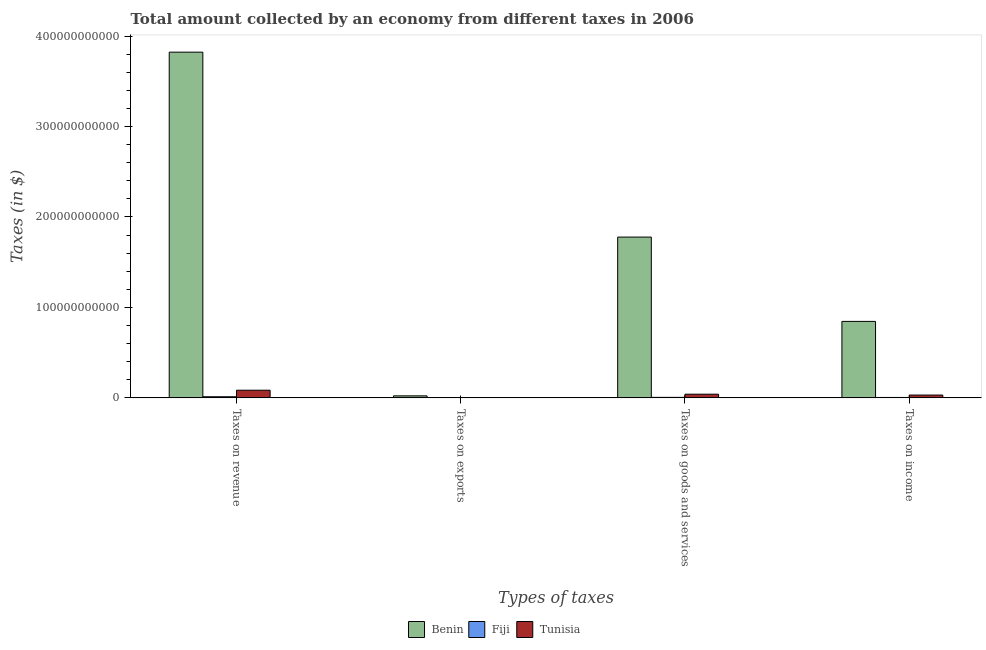How many different coloured bars are there?
Ensure brevity in your answer.  3. How many groups of bars are there?
Offer a terse response. 4. How many bars are there on the 1st tick from the left?
Offer a very short reply. 3. How many bars are there on the 1st tick from the right?
Your answer should be compact. 3. What is the label of the 4th group of bars from the left?
Provide a succinct answer. Taxes on income. What is the amount collected as tax on goods in Tunisia?
Give a very brief answer. 4.06e+09. Across all countries, what is the maximum amount collected as tax on goods?
Your answer should be very brief. 1.78e+11. Across all countries, what is the minimum amount collected as tax on goods?
Your answer should be compact. 5.62e+08. In which country was the amount collected as tax on revenue maximum?
Ensure brevity in your answer.  Benin. In which country was the amount collected as tax on income minimum?
Your answer should be compact. Fiji. What is the total amount collected as tax on goods in the graph?
Give a very brief answer. 1.82e+11. What is the difference between the amount collected as tax on revenue in Tunisia and that in Benin?
Provide a short and direct response. -3.74e+11. What is the difference between the amount collected as tax on exports in Fiji and the amount collected as tax on income in Benin?
Your answer should be very brief. -8.45e+1. What is the average amount collected as tax on goods per country?
Offer a terse response. 6.08e+1. What is the difference between the amount collected as tax on exports and amount collected as tax on goods in Fiji?
Keep it short and to the point. -5.53e+08. In how many countries, is the amount collected as tax on goods greater than 160000000000 $?
Keep it short and to the point. 1. What is the ratio of the amount collected as tax on revenue in Tunisia to that in Benin?
Your answer should be compact. 0.02. What is the difference between the highest and the second highest amount collected as tax on income?
Your answer should be very brief. 8.14e+1. What is the difference between the highest and the lowest amount collected as tax on income?
Your answer should be very brief. 8.41e+1. Is the sum of the amount collected as tax on exports in Fiji and Benin greater than the maximum amount collected as tax on income across all countries?
Your answer should be compact. No. What does the 3rd bar from the left in Taxes on income represents?
Make the answer very short. Tunisia. What does the 2nd bar from the right in Taxes on income represents?
Your answer should be compact. Fiji. Is it the case that in every country, the sum of the amount collected as tax on revenue and amount collected as tax on exports is greater than the amount collected as tax on goods?
Make the answer very short. Yes. Are all the bars in the graph horizontal?
Give a very brief answer. No. What is the difference between two consecutive major ticks on the Y-axis?
Offer a very short reply. 1.00e+11. Where does the legend appear in the graph?
Provide a short and direct response. Bottom center. How many legend labels are there?
Your answer should be compact. 3. How are the legend labels stacked?
Your answer should be very brief. Horizontal. What is the title of the graph?
Your answer should be very brief. Total amount collected by an economy from different taxes in 2006. What is the label or title of the X-axis?
Provide a short and direct response. Types of taxes. What is the label or title of the Y-axis?
Offer a terse response. Taxes (in $). What is the Taxes (in $) in Benin in Taxes on revenue?
Keep it short and to the point. 3.82e+11. What is the Taxes (in $) of Fiji in Taxes on revenue?
Your answer should be very brief. 1.25e+09. What is the Taxes (in $) in Tunisia in Taxes on revenue?
Keep it short and to the point. 8.47e+09. What is the Taxes (in $) of Benin in Taxes on exports?
Offer a terse response. 2.23e+09. What is the Taxes (in $) in Fiji in Taxes on exports?
Offer a very short reply. 8.72e+06. What is the Taxes (in $) of Tunisia in Taxes on exports?
Give a very brief answer. 1.10e+07. What is the Taxes (in $) of Benin in Taxes on goods and services?
Your response must be concise. 1.78e+11. What is the Taxes (in $) in Fiji in Taxes on goods and services?
Offer a very short reply. 5.62e+08. What is the Taxes (in $) of Tunisia in Taxes on goods and services?
Keep it short and to the point. 4.06e+09. What is the Taxes (in $) in Benin in Taxes on income?
Your response must be concise. 8.45e+1. What is the Taxes (in $) in Fiji in Taxes on income?
Provide a short and direct response. 4.46e+08. What is the Taxes (in $) in Tunisia in Taxes on income?
Give a very brief answer. 3.11e+09. Across all Types of taxes, what is the maximum Taxes (in $) of Benin?
Make the answer very short. 3.82e+11. Across all Types of taxes, what is the maximum Taxes (in $) of Fiji?
Your answer should be compact. 1.25e+09. Across all Types of taxes, what is the maximum Taxes (in $) of Tunisia?
Ensure brevity in your answer.  8.47e+09. Across all Types of taxes, what is the minimum Taxes (in $) of Benin?
Keep it short and to the point. 2.23e+09. Across all Types of taxes, what is the minimum Taxes (in $) in Fiji?
Give a very brief answer. 8.72e+06. Across all Types of taxes, what is the minimum Taxes (in $) of Tunisia?
Your answer should be very brief. 1.10e+07. What is the total Taxes (in $) of Benin in the graph?
Offer a terse response. 6.47e+11. What is the total Taxes (in $) in Fiji in the graph?
Offer a very short reply. 2.26e+09. What is the total Taxes (in $) in Tunisia in the graph?
Your response must be concise. 1.56e+1. What is the difference between the Taxes (in $) of Benin in Taxes on revenue and that in Taxes on exports?
Your response must be concise. 3.80e+11. What is the difference between the Taxes (in $) of Fiji in Taxes on revenue and that in Taxes on exports?
Make the answer very short. 1.24e+09. What is the difference between the Taxes (in $) in Tunisia in Taxes on revenue and that in Taxes on exports?
Ensure brevity in your answer.  8.46e+09. What is the difference between the Taxes (in $) of Benin in Taxes on revenue and that in Taxes on goods and services?
Provide a short and direct response. 2.04e+11. What is the difference between the Taxes (in $) of Fiji in Taxes on revenue and that in Taxes on goods and services?
Keep it short and to the point. 6.84e+08. What is the difference between the Taxes (in $) in Tunisia in Taxes on revenue and that in Taxes on goods and services?
Offer a terse response. 4.41e+09. What is the difference between the Taxes (in $) of Benin in Taxes on revenue and that in Taxes on income?
Provide a short and direct response. 2.98e+11. What is the difference between the Taxes (in $) of Fiji in Taxes on revenue and that in Taxes on income?
Your response must be concise. 7.99e+08. What is the difference between the Taxes (in $) in Tunisia in Taxes on revenue and that in Taxes on income?
Keep it short and to the point. 5.36e+09. What is the difference between the Taxes (in $) in Benin in Taxes on exports and that in Taxes on goods and services?
Give a very brief answer. -1.76e+11. What is the difference between the Taxes (in $) of Fiji in Taxes on exports and that in Taxes on goods and services?
Keep it short and to the point. -5.53e+08. What is the difference between the Taxes (in $) in Tunisia in Taxes on exports and that in Taxes on goods and services?
Offer a terse response. -4.05e+09. What is the difference between the Taxes (in $) of Benin in Taxes on exports and that in Taxes on income?
Give a very brief answer. -8.23e+1. What is the difference between the Taxes (in $) in Fiji in Taxes on exports and that in Taxes on income?
Offer a terse response. -4.37e+08. What is the difference between the Taxes (in $) of Tunisia in Taxes on exports and that in Taxes on income?
Offer a very short reply. -3.10e+09. What is the difference between the Taxes (in $) in Benin in Taxes on goods and services and that in Taxes on income?
Offer a very short reply. 9.32e+1. What is the difference between the Taxes (in $) in Fiji in Taxes on goods and services and that in Taxes on income?
Offer a terse response. 1.15e+08. What is the difference between the Taxes (in $) in Tunisia in Taxes on goods and services and that in Taxes on income?
Ensure brevity in your answer.  9.50e+08. What is the difference between the Taxes (in $) of Benin in Taxes on revenue and the Taxes (in $) of Fiji in Taxes on exports?
Your response must be concise. 3.82e+11. What is the difference between the Taxes (in $) in Benin in Taxes on revenue and the Taxes (in $) in Tunisia in Taxes on exports?
Your response must be concise. 3.82e+11. What is the difference between the Taxes (in $) in Fiji in Taxes on revenue and the Taxes (in $) in Tunisia in Taxes on exports?
Give a very brief answer. 1.23e+09. What is the difference between the Taxes (in $) in Benin in Taxes on revenue and the Taxes (in $) in Fiji in Taxes on goods and services?
Ensure brevity in your answer.  3.82e+11. What is the difference between the Taxes (in $) in Benin in Taxes on revenue and the Taxes (in $) in Tunisia in Taxes on goods and services?
Your response must be concise. 3.78e+11. What is the difference between the Taxes (in $) in Fiji in Taxes on revenue and the Taxes (in $) in Tunisia in Taxes on goods and services?
Your answer should be very brief. -2.81e+09. What is the difference between the Taxes (in $) of Benin in Taxes on revenue and the Taxes (in $) of Fiji in Taxes on income?
Ensure brevity in your answer.  3.82e+11. What is the difference between the Taxes (in $) of Benin in Taxes on revenue and the Taxes (in $) of Tunisia in Taxes on income?
Provide a succinct answer. 3.79e+11. What is the difference between the Taxes (in $) in Fiji in Taxes on revenue and the Taxes (in $) in Tunisia in Taxes on income?
Ensure brevity in your answer.  -1.86e+09. What is the difference between the Taxes (in $) in Benin in Taxes on exports and the Taxes (in $) in Fiji in Taxes on goods and services?
Give a very brief answer. 1.67e+09. What is the difference between the Taxes (in $) in Benin in Taxes on exports and the Taxes (in $) in Tunisia in Taxes on goods and services?
Keep it short and to the point. -1.83e+09. What is the difference between the Taxes (in $) of Fiji in Taxes on exports and the Taxes (in $) of Tunisia in Taxes on goods and services?
Offer a terse response. -4.05e+09. What is the difference between the Taxes (in $) of Benin in Taxes on exports and the Taxes (in $) of Fiji in Taxes on income?
Your response must be concise. 1.78e+09. What is the difference between the Taxes (in $) in Benin in Taxes on exports and the Taxes (in $) in Tunisia in Taxes on income?
Provide a succinct answer. -8.77e+08. What is the difference between the Taxes (in $) of Fiji in Taxes on exports and the Taxes (in $) of Tunisia in Taxes on income?
Keep it short and to the point. -3.10e+09. What is the difference between the Taxes (in $) of Benin in Taxes on goods and services and the Taxes (in $) of Fiji in Taxes on income?
Your answer should be compact. 1.77e+11. What is the difference between the Taxes (in $) in Benin in Taxes on goods and services and the Taxes (in $) in Tunisia in Taxes on income?
Make the answer very short. 1.75e+11. What is the difference between the Taxes (in $) of Fiji in Taxes on goods and services and the Taxes (in $) of Tunisia in Taxes on income?
Your answer should be very brief. -2.55e+09. What is the average Taxes (in $) in Benin per Types of taxes?
Your answer should be very brief. 1.62e+11. What is the average Taxes (in $) of Fiji per Types of taxes?
Your answer should be very brief. 5.65e+08. What is the average Taxes (in $) of Tunisia per Types of taxes?
Ensure brevity in your answer.  3.91e+09. What is the difference between the Taxes (in $) of Benin and Taxes (in $) of Fiji in Taxes on revenue?
Ensure brevity in your answer.  3.81e+11. What is the difference between the Taxes (in $) of Benin and Taxes (in $) of Tunisia in Taxes on revenue?
Your answer should be compact. 3.74e+11. What is the difference between the Taxes (in $) in Fiji and Taxes (in $) in Tunisia in Taxes on revenue?
Offer a terse response. -7.22e+09. What is the difference between the Taxes (in $) in Benin and Taxes (in $) in Fiji in Taxes on exports?
Provide a short and direct response. 2.22e+09. What is the difference between the Taxes (in $) of Benin and Taxes (in $) of Tunisia in Taxes on exports?
Your answer should be very brief. 2.22e+09. What is the difference between the Taxes (in $) in Fiji and Taxes (in $) in Tunisia in Taxes on exports?
Make the answer very short. -2.28e+06. What is the difference between the Taxes (in $) of Benin and Taxes (in $) of Fiji in Taxes on goods and services?
Make the answer very short. 1.77e+11. What is the difference between the Taxes (in $) in Benin and Taxes (in $) in Tunisia in Taxes on goods and services?
Provide a succinct answer. 1.74e+11. What is the difference between the Taxes (in $) in Fiji and Taxes (in $) in Tunisia in Taxes on goods and services?
Your response must be concise. -3.50e+09. What is the difference between the Taxes (in $) of Benin and Taxes (in $) of Fiji in Taxes on income?
Your answer should be very brief. 8.41e+1. What is the difference between the Taxes (in $) in Benin and Taxes (in $) in Tunisia in Taxes on income?
Your answer should be compact. 8.14e+1. What is the difference between the Taxes (in $) in Fiji and Taxes (in $) in Tunisia in Taxes on income?
Provide a succinct answer. -2.66e+09. What is the ratio of the Taxes (in $) in Benin in Taxes on revenue to that in Taxes on exports?
Give a very brief answer. 171.4. What is the ratio of the Taxes (in $) of Fiji in Taxes on revenue to that in Taxes on exports?
Ensure brevity in your answer.  142.86. What is the ratio of the Taxes (in $) of Tunisia in Taxes on revenue to that in Taxes on exports?
Your response must be concise. 769.98. What is the ratio of the Taxes (in $) in Benin in Taxes on revenue to that in Taxes on goods and services?
Keep it short and to the point. 2.15. What is the ratio of the Taxes (in $) of Fiji in Taxes on revenue to that in Taxes on goods and services?
Your answer should be compact. 2.22. What is the ratio of the Taxes (in $) of Tunisia in Taxes on revenue to that in Taxes on goods and services?
Your answer should be compact. 2.09. What is the ratio of the Taxes (in $) of Benin in Taxes on revenue to that in Taxes on income?
Your answer should be very brief. 4.52. What is the ratio of the Taxes (in $) of Fiji in Taxes on revenue to that in Taxes on income?
Your answer should be very brief. 2.79. What is the ratio of the Taxes (in $) of Tunisia in Taxes on revenue to that in Taxes on income?
Provide a succinct answer. 2.73. What is the ratio of the Taxes (in $) of Benin in Taxes on exports to that in Taxes on goods and services?
Offer a terse response. 0.01. What is the ratio of the Taxes (in $) in Fiji in Taxes on exports to that in Taxes on goods and services?
Offer a terse response. 0.02. What is the ratio of the Taxes (in $) of Tunisia in Taxes on exports to that in Taxes on goods and services?
Make the answer very short. 0. What is the ratio of the Taxes (in $) of Benin in Taxes on exports to that in Taxes on income?
Your response must be concise. 0.03. What is the ratio of the Taxes (in $) of Fiji in Taxes on exports to that in Taxes on income?
Make the answer very short. 0.02. What is the ratio of the Taxes (in $) in Tunisia in Taxes on exports to that in Taxes on income?
Your answer should be compact. 0. What is the ratio of the Taxes (in $) of Benin in Taxes on goods and services to that in Taxes on income?
Ensure brevity in your answer.  2.1. What is the ratio of the Taxes (in $) of Fiji in Taxes on goods and services to that in Taxes on income?
Keep it short and to the point. 1.26. What is the ratio of the Taxes (in $) of Tunisia in Taxes on goods and services to that in Taxes on income?
Give a very brief answer. 1.31. What is the difference between the highest and the second highest Taxes (in $) of Benin?
Your answer should be very brief. 2.04e+11. What is the difference between the highest and the second highest Taxes (in $) of Fiji?
Your answer should be compact. 6.84e+08. What is the difference between the highest and the second highest Taxes (in $) in Tunisia?
Keep it short and to the point. 4.41e+09. What is the difference between the highest and the lowest Taxes (in $) in Benin?
Your answer should be compact. 3.80e+11. What is the difference between the highest and the lowest Taxes (in $) in Fiji?
Your answer should be very brief. 1.24e+09. What is the difference between the highest and the lowest Taxes (in $) of Tunisia?
Keep it short and to the point. 8.46e+09. 